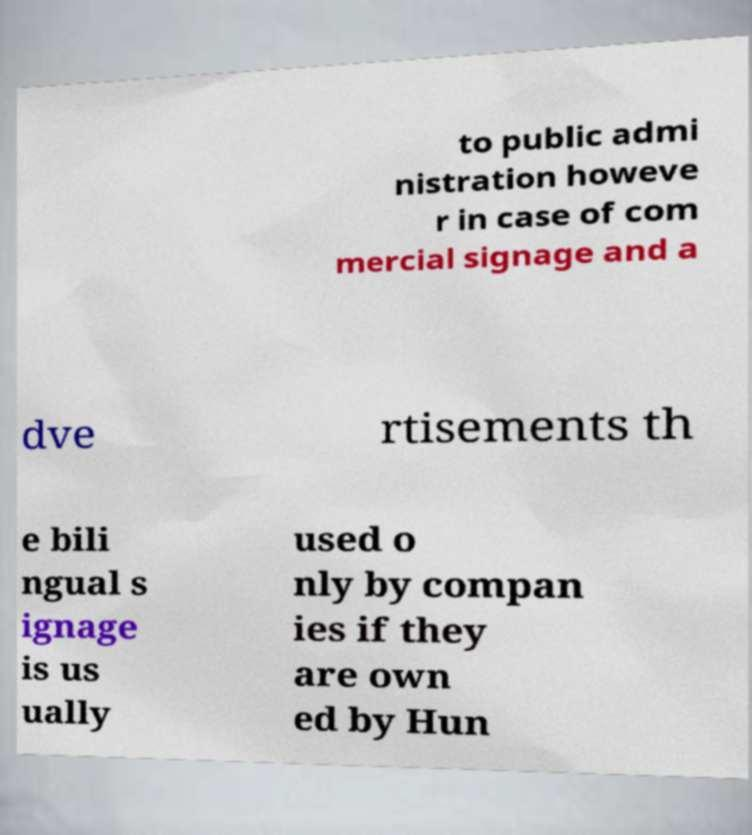Please read and relay the text visible in this image. What does it say? to public admi nistration howeve r in case of com mercial signage and a dve rtisements th e bili ngual s ignage is us ually used o nly by compan ies if they are own ed by Hun 